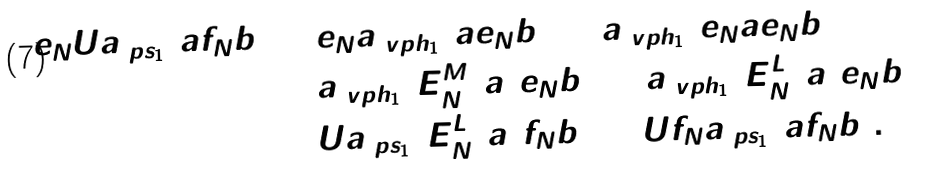<formula> <loc_0><loc_0><loc_500><loc_500>e _ { N } U \L a _ { \ p s _ { 1 } } ( a f _ { N } b ) = & \, e _ { N } \L a _ { \ v p h _ { 1 } } ( a e _ { N } b ) = \L a _ { \ v p h _ { 1 } } ( e _ { N } a e _ { N } b ) \\ = & \, \L a _ { \ v p h _ { 1 } } ( E _ { N } ^ { M } ( a ) e _ { N } b ) = \L a _ { \ v p h _ { 1 } } ( E _ { N } ^ { L } ( a ) e _ { N } b ) \\ = & \, U \L a _ { \ p s _ { 1 } } ( E _ { N } ^ { L } ( a ) f _ { N } b ) = U f _ { N } \L a _ { \ p s _ { 1 } } ( a f _ { N } b ) .</formula> 